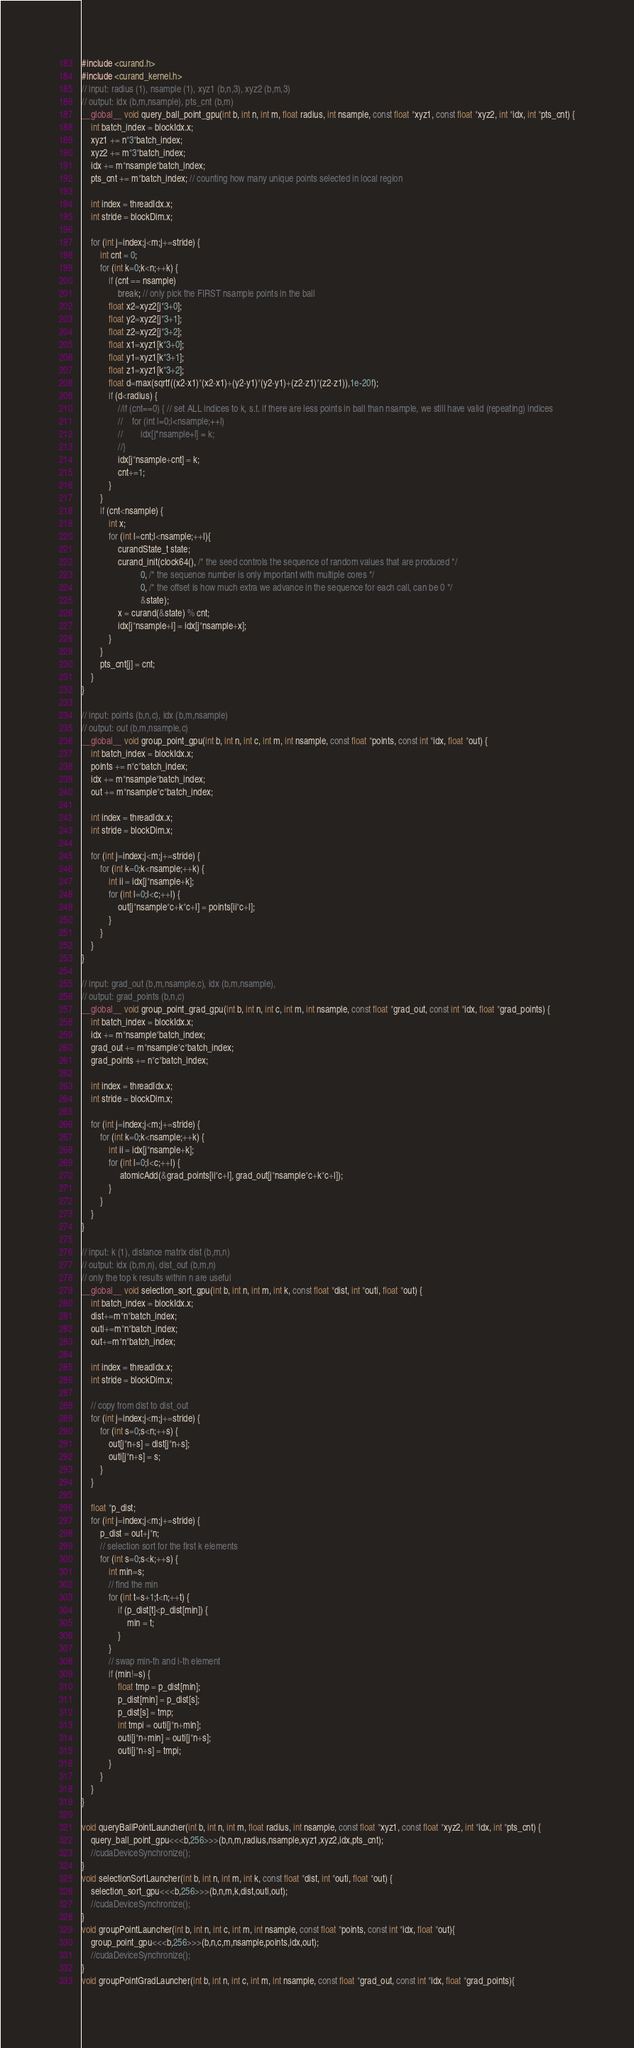<code> <loc_0><loc_0><loc_500><loc_500><_Cuda_>#include <curand.h>
#include <curand_kernel.h>
// input: radius (1), nsample (1), xyz1 (b,n,3), xyz2 (b,m,3)
// output: idx (b,m,nsample), pts_cnt (b,m)
__global__ void query_ball_point_gpu(int b, int n, int m, float radius, int nsample, const float *xyz1, const float *xyz2, int *idx, int *pts_cnt) {
    int batch_index = blockIdx.x;
    xyz1 += n*3*batch_index;
    xyz2 += m*3*batch_index;
    idx += m*nsample*batch_index;
    pts_cnt += m*batch_index; // counting how many unique points selected in local region

    int index = threadIdx.x;
    int stride = blockDim.x;
    
    for (int j=index;j<m;j+=stride) {
        int cnt = 0;
        for (int k=0;k<n;++k) {
            if (cnt == nsample)
                break; // only pick the FIRST nsample points in the ball
            float x2=xyz2[j*3+0];
            float y2=xyz2[j*3+1];
            float z2=xyz2[j*3+2];
            float x1=xyz1[k*3+0];
            float y1=xyz1[k*3+1];
            float z1=xyz1[k*3+2];
    	    float d=max(sqrtf((x2-x1)*(x2-x1)+(y2-y1)*(y2-y1)+(z2-z1)*(z2-z1)),1e-20f);
            if (d<radius) {
                //if (cnt==0) { // set ALL indices to k, s.t. if there are less points in ball than nsample, we still have valid (repeating) indices
                //    for (int l=0;l<nsample;++l)
                //        idx[j*nsample+l] = k;
                //}
                idx[j*nsample+cnt] = k;
                cnt+=1;
            }
        }
        if (cnt<nsample) {
            int x;
            for (int l=cnt;l<nsample;++l){
                curandState_t state;
                curand_init(clock64(), /* the seed controls the sequence of random values that are produced */
                          0, /* the sequence number is only important with multiple cores */
                          0, /* the offset is how much extra we advance in the sequence for each call, can be 0 */
                          &state);
                x = curand(&state) % cnt;
                idx[j*nsample+l] = idx[j*nsample+x];
            }
        }
        pts_cnt[j] = cnt;
    }
}

// input: points (b,n,c), idx (b,m,nsample)
// output: out (b,m,nsample,c)
__global__ void group_point_gpu(int b, int n, int c, int m, int nsample, const float *points, const int *idx, float *out) {
    int batch_index = blockIdx.x;
    points += n*c*batch_index;
    idx += m*nsample*batch_index;
    out += m*nsample*c*batch_index;

    int index = threadIdx.x;
    int stride = blockDim.x;
    
    for (int j=index;j<m;j+=stride) {
        for (int k=0;k<nsample;++k) {
            int ii = idx[j*nsample+k];
            for (int l=0;l<c;++l) {
                out[j*nsample*c+k*c+l] = points[ii*c+l];
            }
        }
    }
}

// input: grad_out (b,m,nsample,c), idx (b,m,nsample), 
// output: grad_points (b,n,c)
__global__ void group_point_grad_gpu(int b, int n, int c, int m, int nsample, const float *grad_out, const int *idx, float *grad_points) {
    int batch_index = blockIdx.x;
    idx += m*nsample*batch_index;
    grad_out += m*nsample*c*batch_index;
    grad_points += n*c*batch_index;

    int index = threadIdx.x;
    int stride = blockDim.x;

    for (int j=index;j<m;j+=stride) {
        for (int k=0;k<nsample;++k) {
            int ii = idx[j*nsample+k];
            for (int l=0;l<c;++l) {
                 atomicAdd(&grad_points[ii*c+l], grad_out[j*nsample*c+k*c+l]);
            }
        }
    }
}

// input: k (1), distance matrix dist (b,m,n)
// output: idx (b,m,n), dist_out (b,m,n)
// only the top k results within n are useful
__global__ void selection_sort_gpu(int b, int n, int m, int k, const float *dist, int *outi, float *out) {
    int batch_index = blockIdx.x;
    dist+=m*n*batch_index;
    outi+=m*n*batch_index;
    out+=m*n*batch_index;

    int index = threadIdx.x;
    int stride = blockDim.x;

    // copy from dist to dist_out
    for (int j=index;j<m;j+=stride) {
        for (int s=0;s<n;++s) {
            out[j*n+s] = dist[j*n+s];
            outi[j*n+s] = s;
        }
    }

    float *p_dist;
    for (int j=index;j<m;j+=stride) {
        p_dist = out+j*n;
        // selection sort for the first k elements
        for (int s=0;s<k;++s) {
            int min=s; 
            // find the min
            for (int t=s+1;t<n;++t) {
                if (p_dist[t]<p_dist[min]) {
                    min = t;
                }
            }
            // swap min-th and i-th element
            if (min!=s) {
                float tmp = p_dist[min];
                p_dist[min] = p_dist[s];
                p_dist[s] = tmp;
                int tmpi = outi[j*n+min];
                outi[j*n+min] = outi[j*n+s];
                outi[j*n+s] = tmpi;
            }
        }
    }
}

void queryBallPointLauncher(int b, int n, int m, float radius, int nsample, const float *xyz1, const float *xyz2, int *idx, int *pts_cnt) {
    query_ball_point_gpu<<<b,256>>>(b,n,m,radius,nsample,xyz1,xyz2,idx,pts_cnt);
    //cudaDeviceSynchronize();
}
void selectionSortLauncher(int b, int n, int m, int k, const float *dist, int *outi, float *out) {
    selection_sort_gpu<<<b,256>>>(b,n,m,k,dist,outi,out); 
    //cudaDeviceSynchronize();
}
void groupPointLauncher(int b, int n, int c, int m, int nsample, const float *points, const int *idx, float *out){
    group_point_gpu<<<b,256>>>(b,n,c,m,nsample,points,idx,out);
    //cudaDeviceSynchronize();
}
void groupPointGradLauncher(int b, int n, int c, int m, int nsample, const float *grad_out, const int *idx, float *grad_points){</code> 